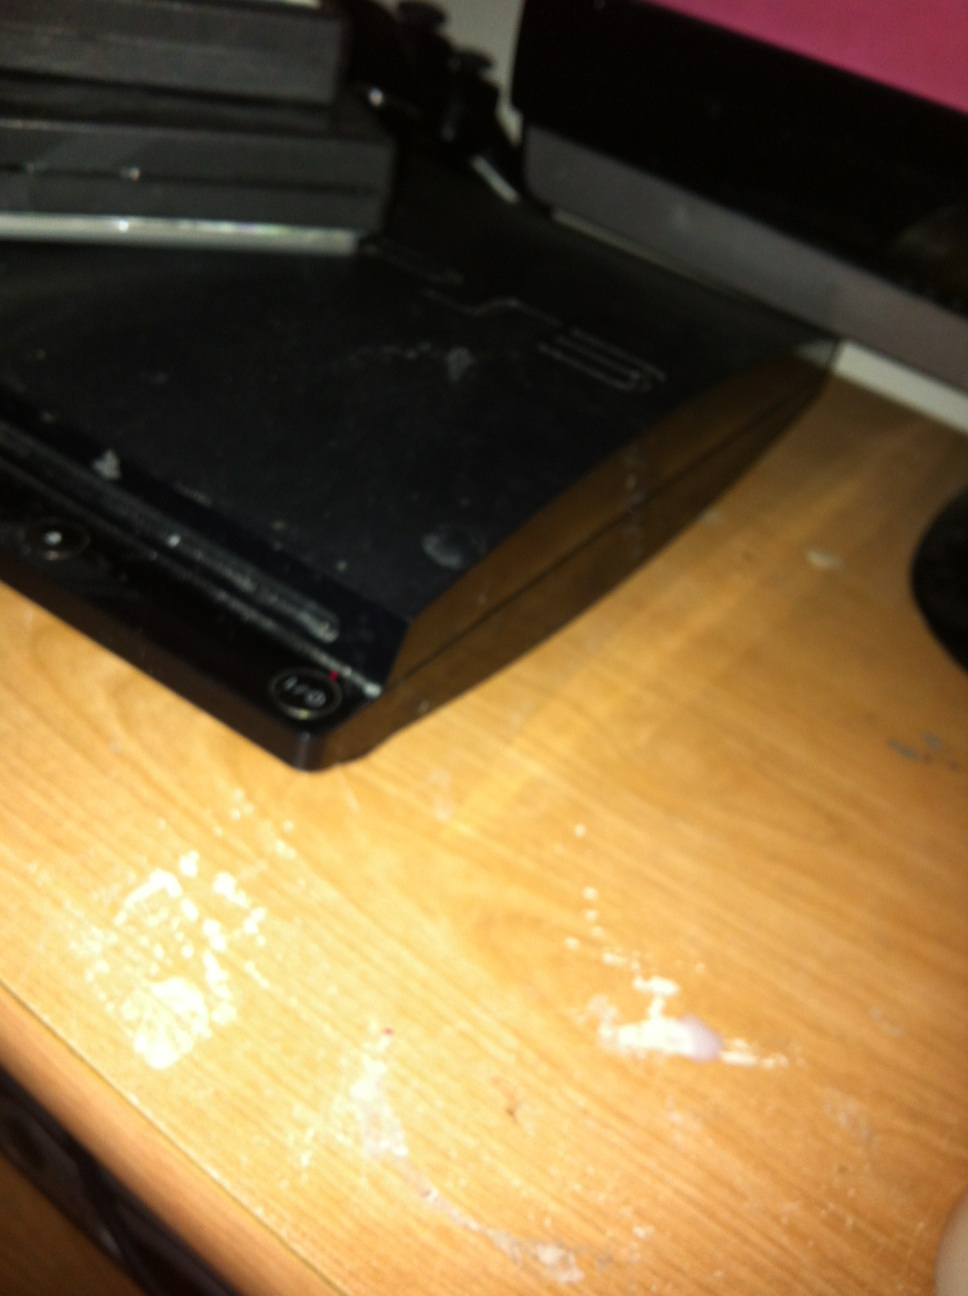Describe a quick interaction with this PlayStation 3 A teenager rushes back home from school, eager to get some gaming time before dinner. They quickly turn on their PlayStation 3 and pop in 'FIFA 14'. Within minutes, they’re on the virtual soccer field, feeling the intensity of the match. The PlayStation 3 effortlessly loads the game, and they skillfully maneuver their team to score a decisive goal, celebrating with a cheer. This brief yet thrilling gaming session recharges them with energy and a sense of accomplishment. 